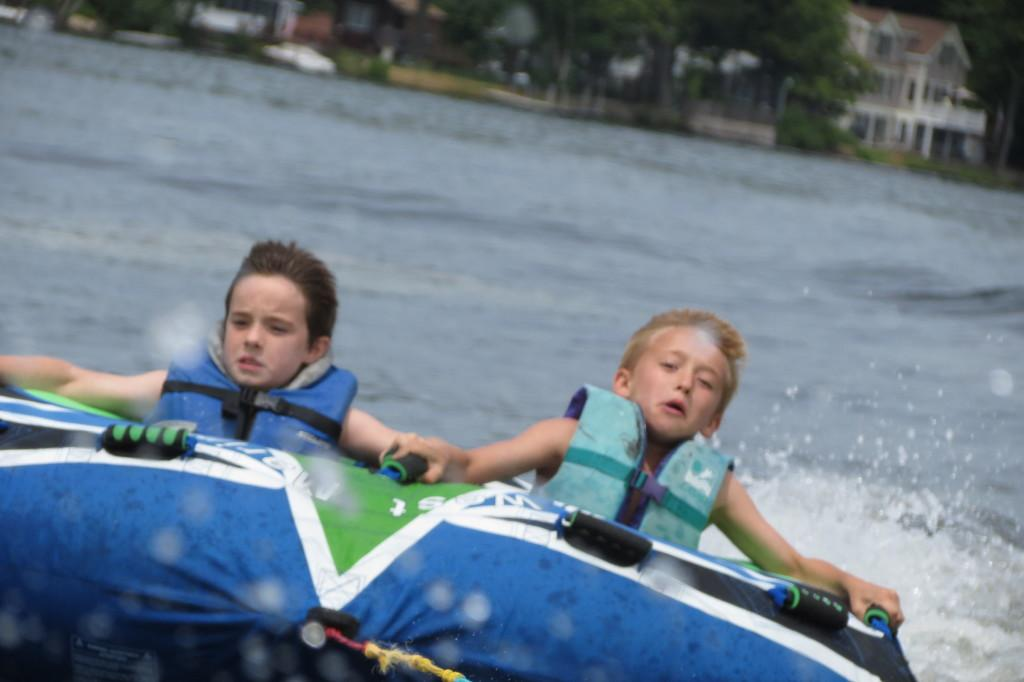How many boys are in the image? There are two boys in the image. What are the boys doing in the image? The boys are sitting on a boat. What can be seen in the background of the image? There is a lake, a building, and trees in the background of the image. What type of record can be seen in the hands of the boys in the image? There are no records present in the image; the boys are sitting on a boat in a lake with a building and trees in the background. 